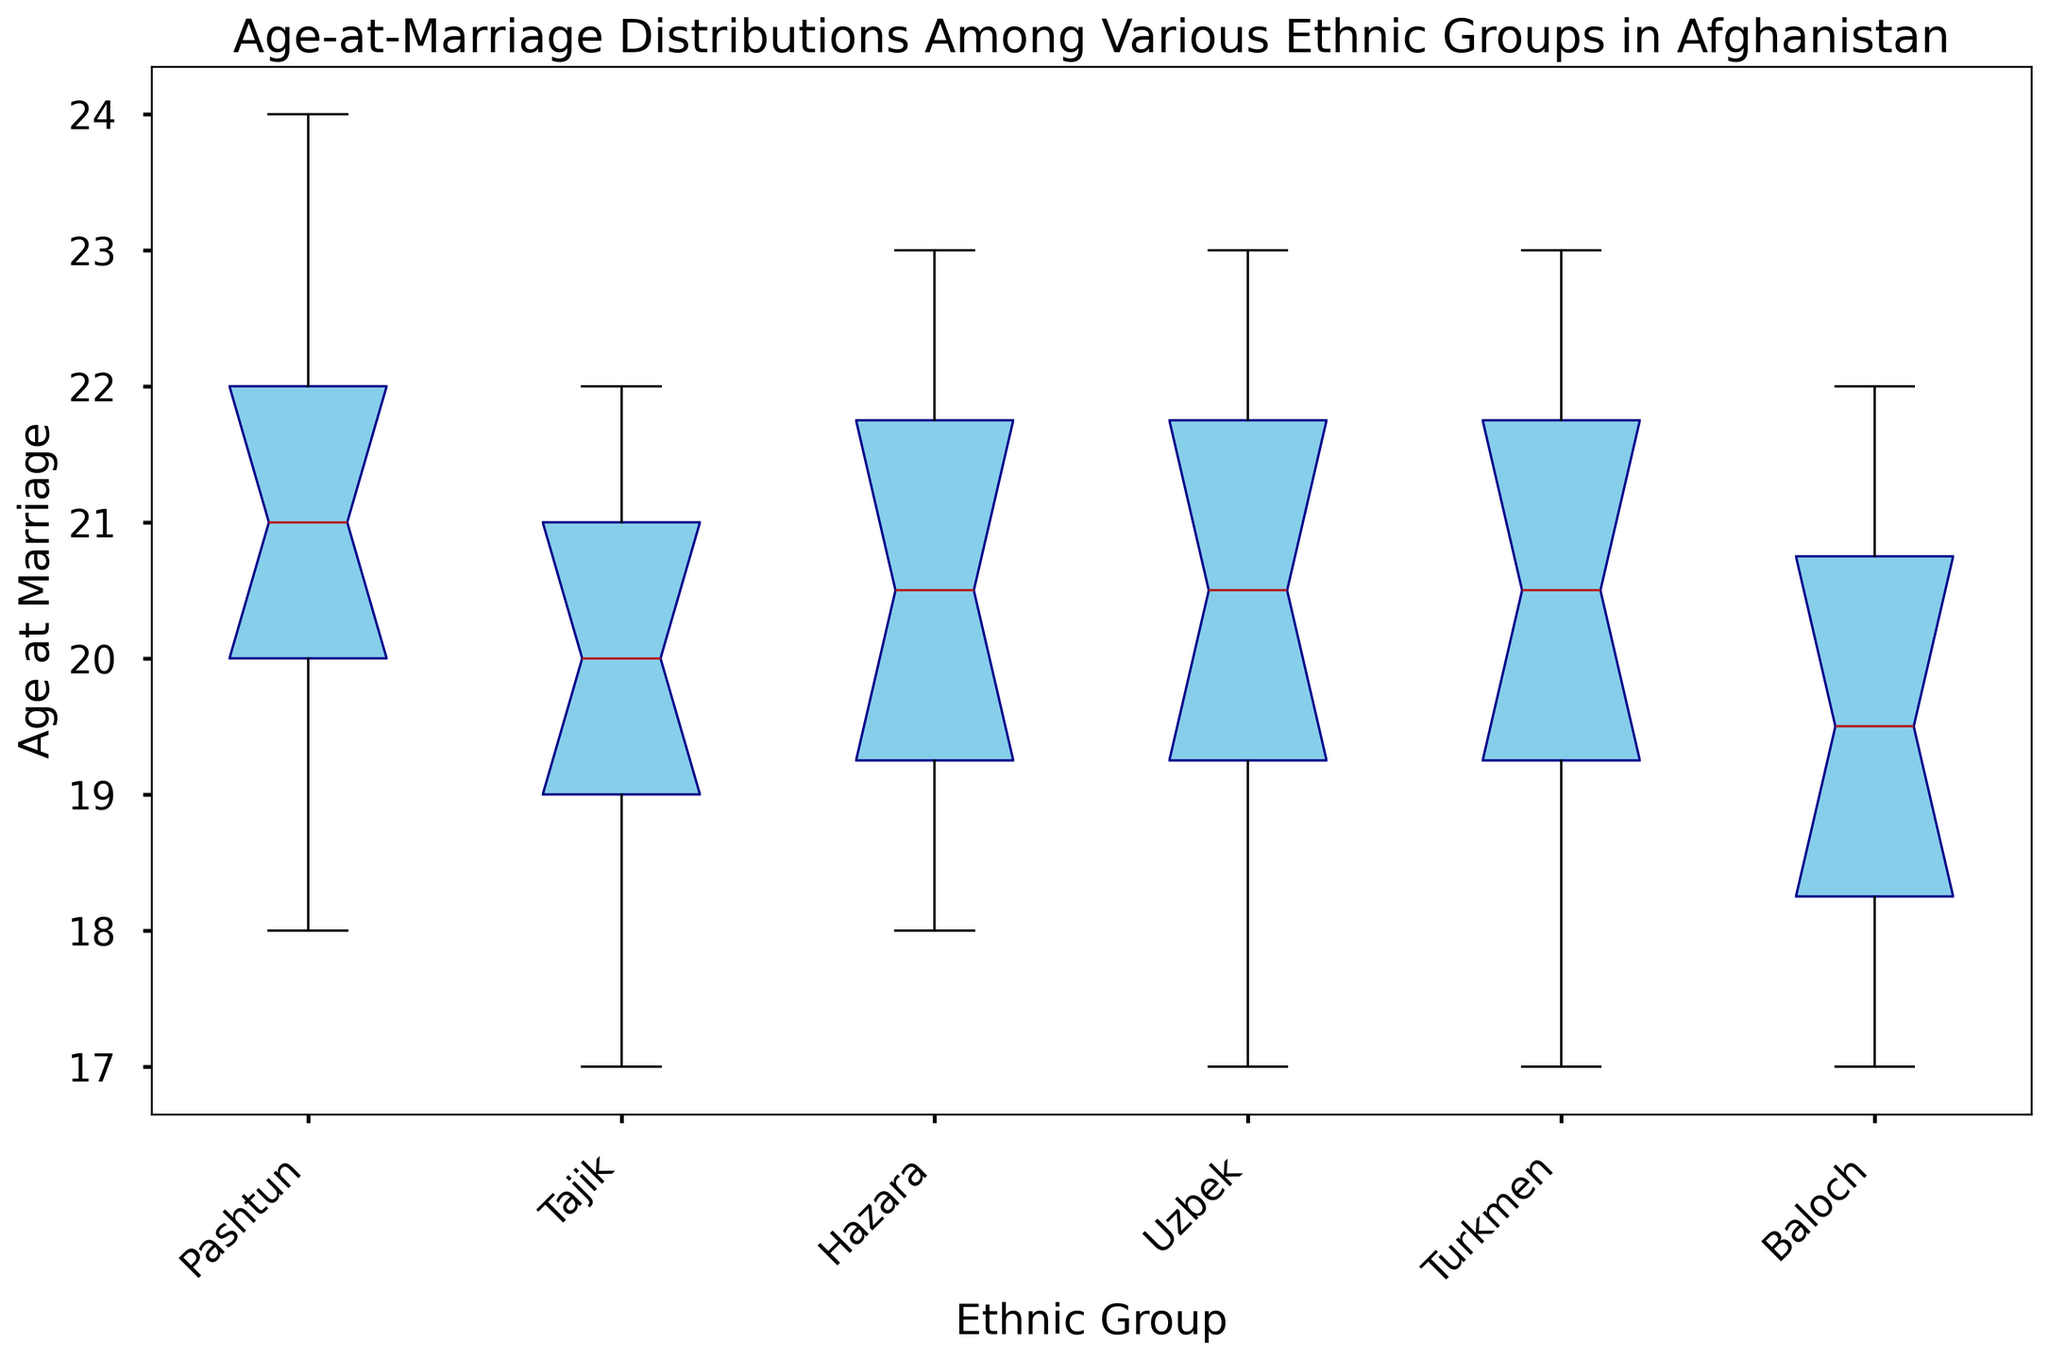Which ethnic group has the lowest median age at marriage? Look at the line inside each box. The lowest median line appears in the box for the Uzbek group.
Answer: Uzbek What is the interquartile range (IQR) for the Hazara ethnic group? The IQR is the difference between the third quartile (Q3) and the first quartile (Q1). For Hazara, this is the length of the box. From the plot, estimate Q3 as 22 and Q1 as 19. 22 - 19 = 3.
Answer: 3 Among the Pashtun and Tajik groups, which has a wider range of ages at marriage? Compare the lengths of the whiskers (lines extending from the box) for both groups. The Pashtun group has a wider range since their whiskers are longer.
Answer: Pashtun Which ethnic group has the highest upper whisker value? The upper whisker reaches the highest point in the Turkmen group.
Answer: Turkmen How does the median age at marriage for Pashtun compare to Tajik? Look at the lines inside both boxes. The Pashtun group's median line is slightly higher than the Tajik group's median line.
Answer: Pashtun is higher What's the difference in the median age at marriage between the Pashtun and Turkmen groups? Identify the median lines inside their boxes. Pashtun has a median of 21, Turkmen has a median of 20. The difference is 21 - 20 = 1.
Answer: 1 Which ethnic group has the smallest interquartile range (IQR)? The smallest IQR is the shortest box in height. The Uzbek group has the smallest IQR.
Answer: Uzbek Compare the age-at-marriage distribution among all ethnic groups: which has the highest variability? Look for the group with the widest spread from the lowest whisker to the highest whisker. The Turkmen group appears to have the most spread out values.
Answer: Turkmen Is the median age at marriage of the Hazara group closer to the highest or lowest age of the Uzbek group? The Hazara median is around 21, the Uzbek highest age is 22 and the lowest age is 17. The median is closer to 22.
Answer: Highest Which ethnic group has the most outliers? Look for the group with the most individual points outside the whiskers. From the plot, the Turkmen group shows the most outliers.
Answer: Turkmen 